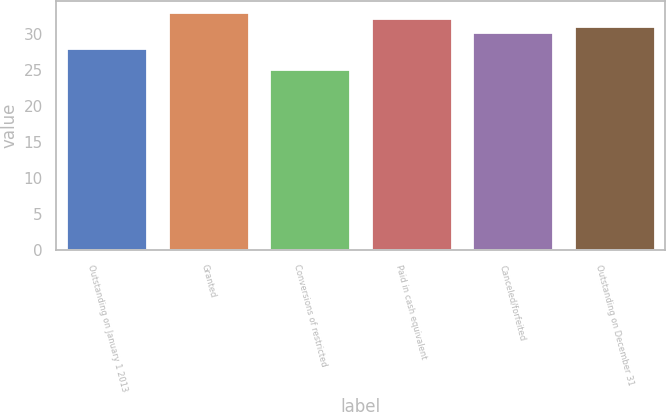Convert chart. <chart><loc_0><loc_0><loc_500><loc_500><bar_chart><fcel>Outstanding on January 1 2013<fcel>Granted<fcel>Conversions of restricted<fcel>Paid in cash equivalent<fcel>Canceled/forfeited<fcel>Outstanding on December 31<nl><fcel>28.01<fcel>33<fcel>25.17<fcel>32.25<fcel>30.33<fcel>31.08<nl></chart> 